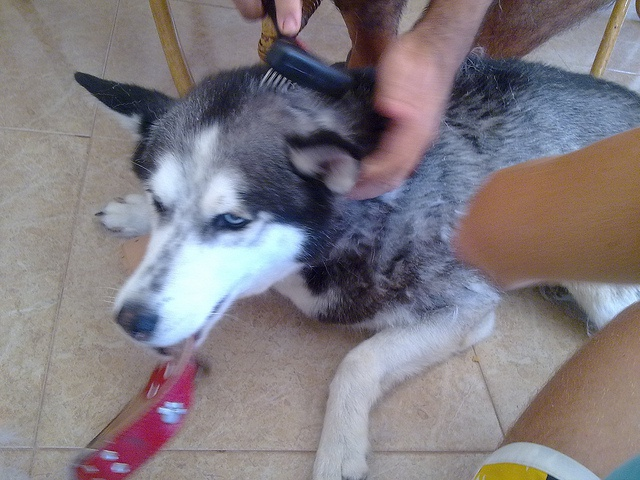Describe the objects in this image and their specific colors. I can see dog in gray, darkgray, and black tones, people in gray tones, and people in gray and lightpink tones in this image. 